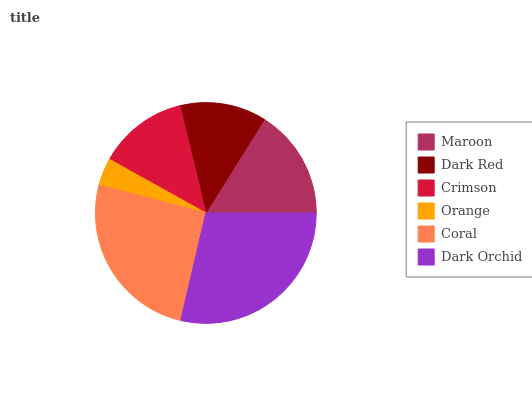Is Orange the minimum?
Answer yes or no. Yes. Is Dark Orchid the maximum?
Answer yes or no. Yes. Is Dark Red the minimum?
Answer yes or no. No. Is Dark Red the maximum?
Answer yes or no. No. Is Maroon greater than Dark Red?
Answer yes or no. Yes. Is Dark Red less than Maroon?
Answer yes or no. Yes. Is Dark Red greater than Maroon?
Answer yes or no. No. Is Maroon less than Dark Red?
Answer yes or no. No. Is Maroon the high median?
Answer yes or no. Yes. Is Crimson the low median?
Answer yes or no. Yes. Is Dark Orchid the high median?
Answer yes or no. No. Is Maroon the low median?
Answer yes or no. No. 